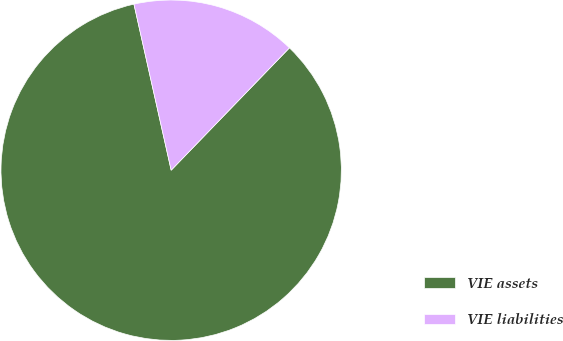Convert chart to OTSL. <chart><loc_0><loc_0><loc_500><loc_500><pie_chart><fcel>VIE assets<fcel>VIE liabilities<nl><fcel>84.26%<fcel>15.74%<nl></chart> 